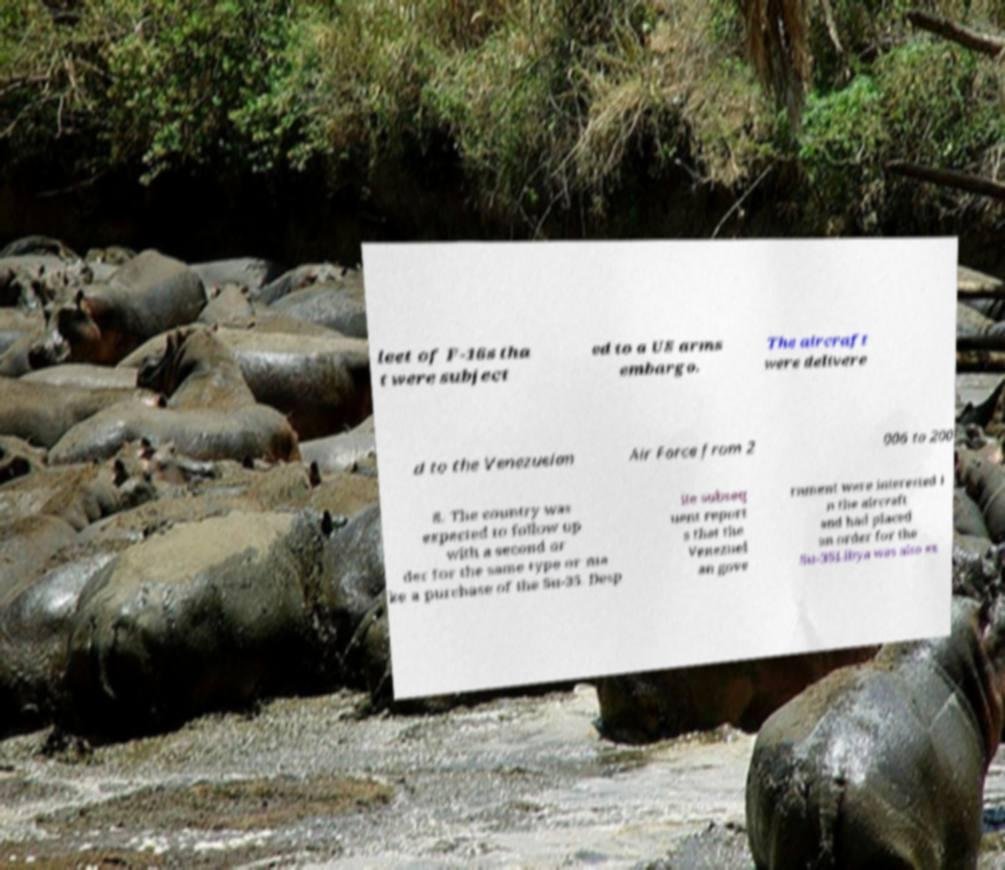Can you read and provide the text displayed in the image?This photo seems to have some interesting text. Can you extract and type it out for me? leet of F-16s tha t were subject ed to a US arms embargo. The aircraft were delivere d to the Venezuelan Air Force from 2 006 to 200 8. The country was expected to follow up with a second or der for the same type or ma ke a purchase of the Su-35. Desp ite subseq uent report s that the Venezuel an gove rnment were interested i n the aircraft and had placed an order for the Su-35Libya was also ex 